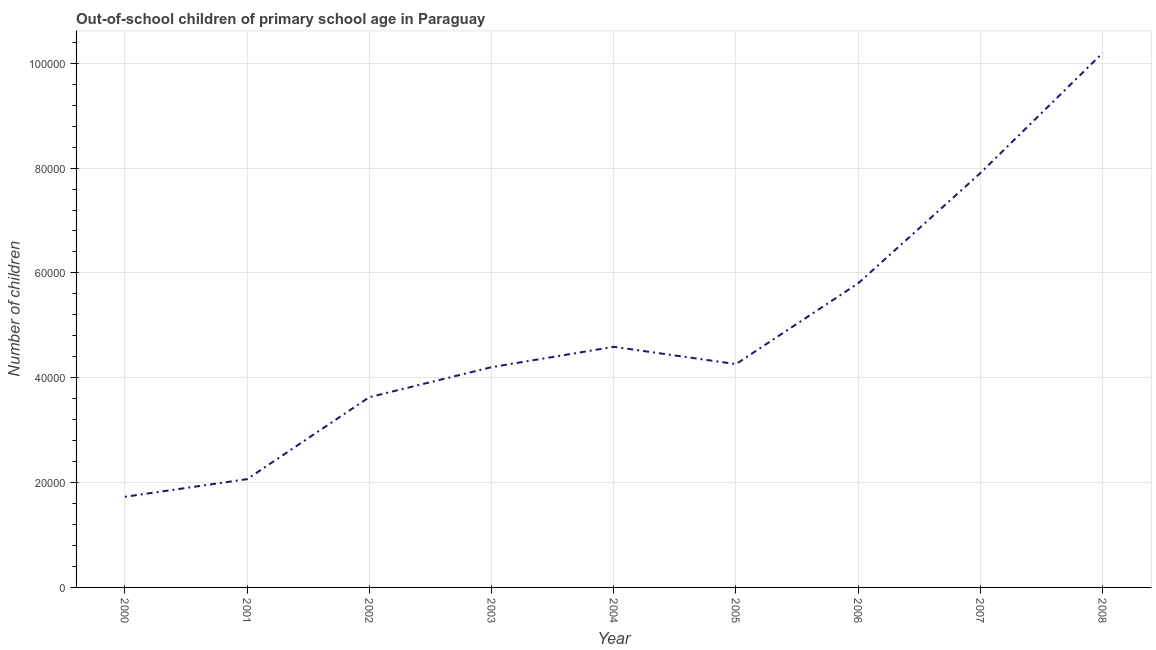What is the number of out-of-school children in 2002?
Ensure brevity in your answer.  3.63e+04. Across all years, what is the maximum number of out-of-school children?
Your response must be concise. 1.02e+05. Across all years, what is the minimum number of out-of-school children?
Your answer should be compact. 1.73e+04. What is the sum of the number of out-of-school children?
Provide a short and direct response. 4.44e+05. What is the difference between the number of out-of-school children in 2002 and 2008?
Ensure brevity in your answer.  -6.57e+04. What is the average number of out-of-school children per year?
Your response must be concise. 4.93e+04. What is the median number of out-of-school children?
Offer a terse response. 4.26e+04. In how many years, is the number of out-of-school children greater than 80000 ?
Offer a terse response. 1. What is the ratio of the number of out-of-school children in 2001 to that in 2004?
Make the answer very short. 0.45. Is the number of out-of-school children in 2000 less than that in 2008?
Make the answer very short. Yes. What is the difference between the highest and the second highest number of out-of-school children?
Make the answer very short. 2.29e+04. Is the sum of the number of out-of-school children in 2002 and 2006 greater than the maximum number of out-of-school children across all years?
Your response must be concise. No. What is the difference between the highest and the lowest number of out-of-school children?
Your answer should be very brief. 8.47e+04. In how many years, is the number of out-of-school children greater than the average number of out-of-school children taken over all years?
Offer a very short reply. 3. Does the number of out-of-school children monotonically increase over the years?
Make the answer very short. No. How many lines are there?
Offer a very short reply. 1. How many years are there in the graph?
Offer a terse response. 9. Are the values on the major ticks of Y-axis written in scientific E-notation?
Your answer should be very brief. No. What is the title of the graph?
Your answer should be very brief. Out-of-school children of primary school age in Paraguay. What is the label or title of the X-axis?
Offer a terse response. Year. What is the label or title of the Y-axis?
Offer a terse response. Number of children. What is the Number of children of 2000?
Offer a terse response. 1.73e+04. What is the Number of children in 2001?
Offer a terse response. 2.07e+04. What is the Number of children of 2002?
Offer a very short reply. 3.63e+04. What is the Number of children of 2003?
Keep it short and to the point. 4.20e+04. What is the Number of children in 2004?
Offer a terse response. 4.59e+04. What is the Number of children of 2005?
Offer a very short reply. 4.26e+04. What is the Number of children of 2006?
Provide a succinct answer. 5.80e+04. What is the Number of children in 2007?
Keep it short and to the point. 7.90e+04. What is the Number of children in 2008?
Offer a very short reply. 1.02e+05. What is the difference between the Number of children in 2000 and 2001?
Keep it short and to the point. -3367. What is the difference between the Number of children in 2000 and 2002?
Offer a terse response. -1.90e+04. What is the difference between the Number of children in 2000 and 2003?
Provide a succinct answer. -2.47e+04. What is the difference between the Number of children in 2000 and 2004?
Ensure brevity in your answer.  -2.86e+04. What is the difference between the Number of children in 2000 and 2005?
Offer a terse response. -2.53e+04. What is the difference between the Number of children in 2000 and 2006?
Offer a very short reply. -4.07e+04. What is the difference between the Number of children in 2000 and 2007?
Ensure brevity in your answer.  -6.18e+04. What is the difference between the Number of children in 2000 and 2008?
Provide a succinct answer. -8.47e+04. What is the difference between the Number of children in 2001 and 2002?
Offer a very short reply. -1.56e+04. What is the difference between the Number of children in 2001 and 2003?
Provide a short and direct response. -2.14e+04. What is the difference between the Number of children in 2001 and 2004?
Provide a short and direct response. -2.52e+04. What is the difference between the Number of children in 2001 and 2005?
Offer a very short reply. -2.19e+04. What is the difference between the Number of children in 2001 and 2006?
Offer a very short reply. -3.74e+04. What is the difference between the Number of children in 2001 and 2007?
Provide a short and direct response. -5.84e+04. What is the difference between the Number of children in 2001 and 2008?
Provide a short and direct response. -8.13e+04. What is the difference between the Number of children in 2002 and 2003?
Your answer should be compact. -5724. What is the difference between the Number of children in 2002 and 2004?
Make the answer very short. -9607. What is the difference between the Number of children in 2002 and 2005?
Make the answer very short. -6308. What is the difference between the Number of children in 2002 and 2006?
Your answer should be very brief. -2.17e+04. What is the difference between the Number of children in 2002 and 2007?
Provide a short and direct response. -4.28e+04. What is the difference between the Number of children in 2002 and 2008?
Offer a very short reply. -6.57e+04. What is the difference between the Number of children in 2003 and 2004?
Your answer should be compact. -3883. What is the difference between the Number of children in 2003 and 2005?
Your response must be concise. -584. What is the difference between the Number of children in 2003 and 2006?
Give a very brief answer. -1.60e+04. What is the difference between the Number of children in 2003 and 2007?
Keep it short and to the point. -3.70e+04. What is the difference between the Number of children in 2003 and 2008?
Your response must be concise. -5.99e+04. What is the difference between the Number of children in 2004 and 2005?
Offer a terse response. 3299. What is the difference between the Number of children in 2004 and 2006?
Offer a terse response. -1.21e+04. What is the difference between the Number of children in 2004 and 2007?
Your response must be concise. -3.31e+04. What is the difference between the Number of children in 2004 and 2008?
Offer a very short reply. -5.61e+04. What is the difference between the Number of children in 2005 and 2006?
Offer a terse response. -1.54e+04. What is the difference between the Number of children in 2005 and 2007?
Provide a succinct answer. -3.64e+04. What is the difference between the Number of children in 2005 and 2008?
Offer a terse response. -5.94e+04. What is the difference between the Number of children in 2006 and 2007?
Give a very brief answer. -2.10e+04. What is the difference between the Number of children in 2006 and 2008?
Offer a terse response. -4.39e+04. What is the difference between the Number of children in 2007 and 2008?
Keep it short and to the point. -2.29e+04. What is the ratio of the Number of children in 2000 to that in 2001?
Give a very brief answer. 0.84. What is the ratio of the Number of children in 2000 to that in 2002?
Provide a short and direct response. 0.48. What is the ratio of the Number of children in 2000 to that in 2003?
Give a very brief answer. 0.41. What is the ratio of the Number of children in 2000 to that in 2004?
Offer a very short reply. 0.38. What is the ratio of the Number of children in 2000 to that in 2005?
Your answer should be compact. 0.41. What is the ratio of the Number of children in 2000 to that in 2006?
Offer a terse response. 0.3. What is the ratio of the Number of children in 2000 to that in 2007?
Ensure brevity in your answer.  0.22. What is the ratio of the Number of children in 2000 to that in 2008?
Offer a very short reply. 0.17. What is the ratio of the Number of children in 2001 to that in 2002?
Provide a succinct answer. 0.57. What is the ratio of the Number of children in 2001 to that in 2003?
Keep it short and to the point. 0.49. What is the ratio of the Number of children in 2001 to that in 2004?
Offer a very short reply. 0.45. What is the ratio of the Number of children in 2001 to that in 2005?
Provide a short and direct response. 0.48. What is the ratio of the Number of children in 2001 to that in 2006?
Your answer should be very brief. 0.36. What is the ratio of the Number of children in 2001 to that in 2007?
Make the answer very short. 0.26. What is the ratio of the Number of children in 2001 to that in 2008?
Keep it short and to the point. 0.2. What is the ratio of the Number of children in 2002 to that in 2003?
Your answer should be compact. 0.86. What is the ratio of the Number of children in 2002 to that in 2004?
Provide a short and direct response. 0.79. What is the ratio of the Number of children in 2002 to that in 2005?
Provide a succinct answer. 0.85. What is the ratio of the Number of children in 2002 to that in 2006?
Offer a very short reply. 0.63. What is the ratio of the Number of children in 2002 to that in 2007?
Your answer should be very brief. 0.46. What is the ratio of the Number of children in 2002 to that in 2008?
Offer a very short reply. 0.36. What is the ratio of the Number of children in 2003 to that in 2004?
Provide a succinct answer. 0.92. What is the ratio of the Number of children in 2003 to that in 2006?
Keep it short and to the point. 0.72. What is the ratio of the Number of children in 2003 to that in 2007?
Your response must be concise. 0.53. What is the ratio of the Number of children in 2003 to that in 2008?
Your response must be concise. 0.41. What is the ratio of the Number of children in 2004 to that in 2005?
Offer a terse response. 1.08. What is the ratio of the Number of children in 2004 to that in 2006?
Provide a short and direct response. 0.79. What is the ratio of the Number of children in 2004 to that in 2007?
Offer a very short reply. 0.58. What is the ratio of the Number of children in 2004 to that in 2008?
Your answer should be compact. 0.45. What is the ratio of the Number of children in 2005 to that in 2006?
Your response must be concise. 0.73. What is the ratio of the Number of children in 2005 to that in 2007?
Provide a short and direct response. 0.54. What is the ratio of the Number of children in 2005 to that in 2008?
Keep it short and to the point. 0.42. What is the ratio of the Number of children in 2006 to that in 2007?
Keep it short and to the point. 0.73. What is the ratio of the Number of children in 2006 to that in 2008?
Keep it short and to the point. 0.57. What is the ratio of the Number of children in 2007 to that in 2008?
Provide a succinct answer. 0.78. 